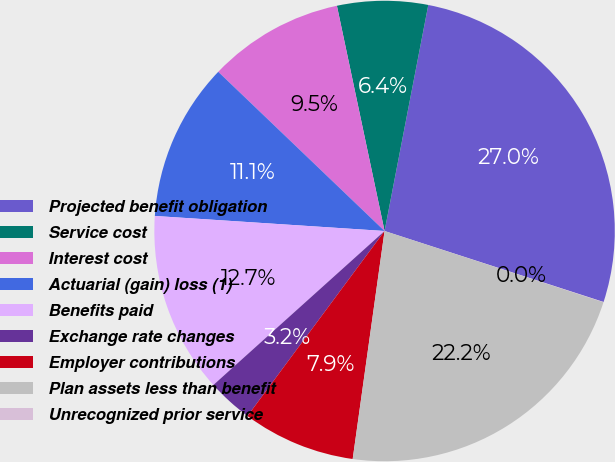Convert chart. <chart><loc_0><loc_0><loc_500><loc_500><pie_chart><fcel>Projected benefit obligation<fcel>Service cost<fcel>Interest cost<fcel>Actuarial (gain) loss (1)<fcel>Benefits paid<fcel>Exchange rate changes<fcel>Employer contributions<fcel>Plan assets less than benefit<fcel>Unrecognized prior service<nl><fcel>26.95%<fcel>6.36%<fcel>9.53%<fcel>11.11%<fcel>12.7%<fcel>3.19%<fcel>7.94%<fcel>22.2%<fcel>0.02%<nl></chart> 